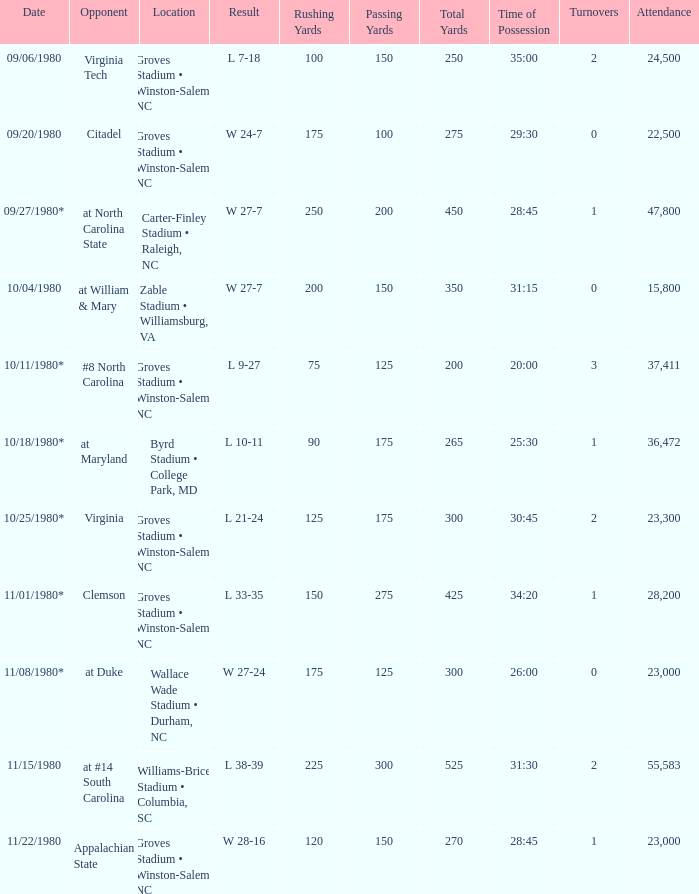How many people attended when Wake Forest played Virginia Tech? 24500.0. 